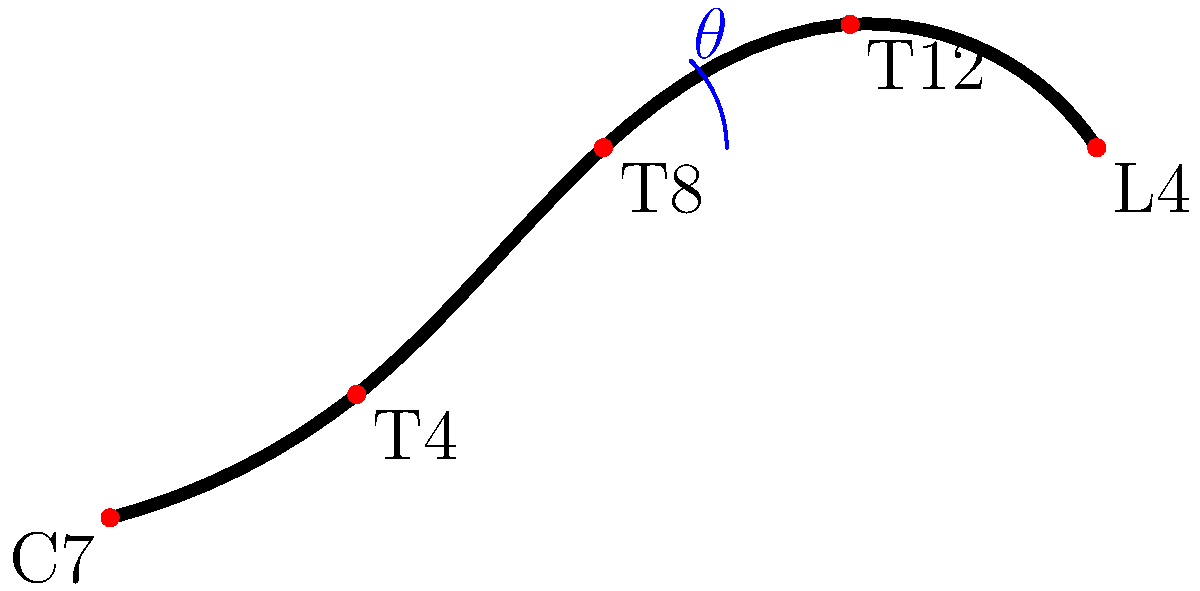In patients with systemic sclerosis, the Cobb angle method is often used to assess spinal curvature. Given the anatomical landmarks shown in the diagram, which represents a lateral view of the spine, calculate the approximate Cobb angle $\theta$ between the T4 and T12 vertebrae. Assume that the angle between the perpendicular lines from these vertebrae is 45°. To calculate the Cobb angle between T4 and T12 vertebrae, we follow these steps:

1. Identify the vertebrae of interest: T4 and T12 are marked on the diagram.

2. Understand the Cobb angle definition: It is the angle between perpendicular lines drawn from the superior endplate of the upper vertebra (T4) and the inferior endplate of the lower vertebra (T12).

3. Note the given information: The angle between the perpendicular lines is 45°.

4. Apply the Cobb angle formula: In this case, the Cobb angle is equal to the angle between the perpendicular lines.

5. Therefore, the Cobb angle $\theta$ is directly given as 45°.

It's important to note that in clinical practice, this angle would be measured more precisely using radiographic images. This simplified diagram provides an approximation for educational purposes.
Answer: 45° 